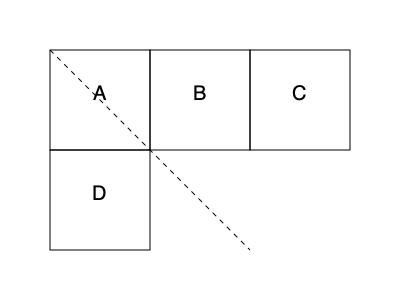In a secure document analysis task, you're presented with a 2D net that, when folded, forms a cube. The net is shown above, where each square represents a face of the cube. If the cube is folded so that face A becomes the bottom, which face will be directly opposite to face C? To solve this problem, we need to mentally fold the 2D net into a 3D cube. Let's follow these steps:

1. Identify the bottom face: Face A is given as the bottom face.

2. Locate face C: Face C is on the right side of the net.

3. Visualize the folding process:
   - Face B will fold up to become the front face.
   - Face C will fold up to become the right face.
   - The unmarked face to the left of A will become the left face.
   - Face D will fold to become the back face.

4. Determine the top face: The face directly opposite to the bottom (A) will be the top face.

5. Identify the face opposite to C: Since C is the right face, the face opposite to it will be the left face.

6. Conclusion: The face directly opposite to C is the unmarked face to the left of A in the 2D net.

This spatial reasoning process is similar to analyzing complex 3D relationships in intelligence data or secure facility layouts, which is relevant to the recruiter's field of expertise.
Answer: The unmarked face left of A 